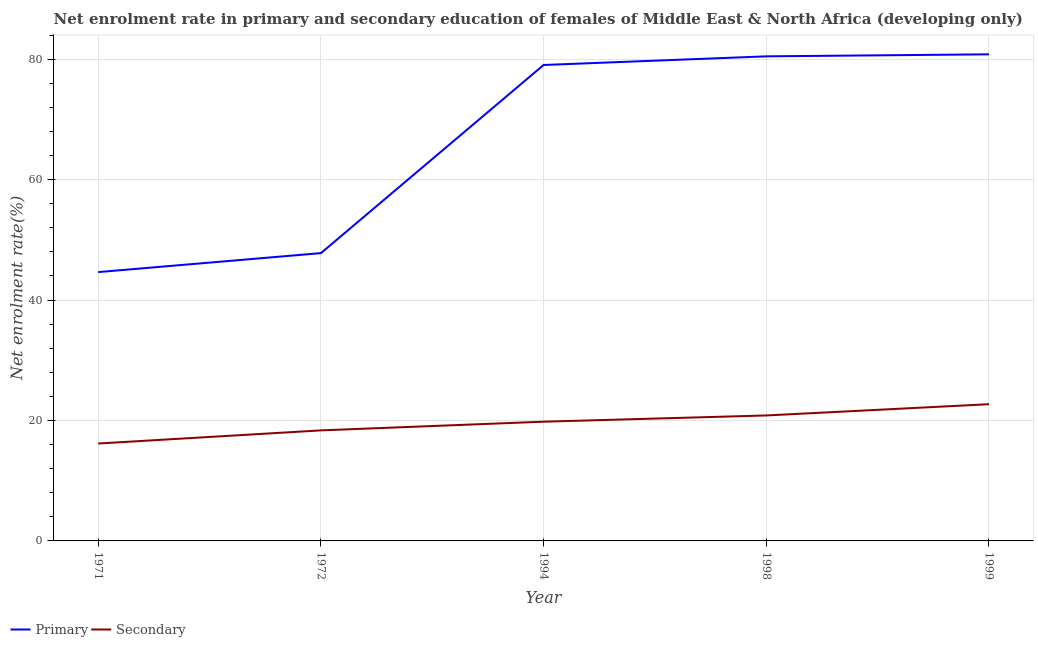How many different coloured lines are there?
Make the answer very short. 2. What is the enrollment rate in secondary education in 1972?
Offer a terse response. 18.36. Across all years, what is the maximum enrollment rate in secondary education?
Offer a terse response. 22.7. Across all years, what is the minimum enrollment rate in primary education?
Offer a very short reply. 44.64. In which year was the enrollment rate in secondary education minimum?
Provide a short and direct response. 1971. What is the total enrollment rate in secondary education in the graph?
Your answer should be very brief. 97.87. What is the difference between the enrollment rate in secondary education in 1998 and that in 1999?
Keep it short and to the point. -1.87. What is the difference between the enrollment rate in primary education in 1972 and the enrollment rate in secondary education in 1998?
Ensure brevity in your answer.  26.96. What is the average enrollment rate in primary education per year?
Offer a terse response. 66.55. In the year 1999, what is the difference between the enrollment rate in secondary education and enrollment rate in primary education?
Provide a succinct answer. -58.1. In how many years, is the enrollment rate in primary education greater than 76 %?
Offer a very short reply. 3. What is the ratio of the enrollment rate in primary education in 1994 to that in 1998?
Give a very brief answer. 0.98. What is the difference between the highest and the second highest enrollment rate in primary education?
Your response must be concise. 0.33. What is the difference between the highest and the lowest enrollment rate in secondary education?
Ensure brevity in your answer.  6.53. In how many years, is the enrollment rate in primary education greater than the average enrollment rate in primary education taken over all years?
Ensure brevity in your answer.  3. Does the enrollment rate in primary education monotonically increase over the years?
Give a very brief answer. Yes. Is the enrollment rate in secondary education strictly less than the enrollment rate in primary education over the years?
Offer a very short reply. Yes. Are the values on the major ticks of Y-axis written in scientific E-notation?
Keep it short and to the point. No. Does the graph contain any zero values?
Your answer should be very brief. No. How many legend labels are there?
Offer a very short reply. 2. What is the title of the graph?
Give a very brief answer. Net enrolment rate in primary and secondary education of females of Middle East & North Africa (developing only). Does "Primary completion rate" appear as one of the legend labels in the graph?
Offer a terse response. No. What is the label or title of the X-axis?
Give a very brief answer. Year. What is the label or title of the Y-axis?
Ensure brevity in your answer.  Net enrolment rate(%). What is the Net enrolment rate(%) in Primary in 1971?
Your answer should be compact. 44.64. What is the Net enrolment rate(%) in Secondary in 1971?
Your response must be concise. 16.17. What is the Net enrolment rate(%) of Primary in 1972?
Your response must be concise. 47.79. What is the Net enrolment rate(%) in Secondary in 1972?
Your answer should be compact. 18.36. What is the Net enrolment rate(%) in Primary in 1994?
Your answer should be very brief. 79.03. What is the Net enrolment rate(%) in Secondary in 1994?
Make the answer very short. 19.8. What is the Net enrolment rate(%) of Primary in 1998?
Give a very brief answer. 80.47. What is the Net enrolment rate(%) in Secondary in 1998?
Provide a succinct answer. 20.83. What is the Net enrolment rate(%) in Primary in 1999?
Make the answer very short. 80.8. What is the Net enrolment rate(%) in Secondary in 1999?
Keep it short and to the point. 22.7. Across all years, what is the maximum Net enrolment rate(%) in Primary?
Your response must be concise. 80.8. Across all years, what is the maximum Net enrolment rate(%) of Secondary?
Your answer should be compact. 22.7. Across all years, what is the minimum Net enrolment rate(%) in Primary?
Make the answer very short. 44.64. Across all years, what is the minimum Net enrolment rate(%) of Secondary?
Provide a short and direct response. 16.17. What is the total Net enrolment rate(%) in Primary in the graph?
Make the answer very short. 332.73. What is the total Net enrolment rate(%) in Secondary in the graph?
Give a very brief answer. 97.87. What is the difference between the Net enrolment rate(%) in Primary in 1971 and that in 1972?
Provide a short and direct response. -3.15. What is the difference between the Net enrolment rate(%) in Secondary in 1971 and that in 1972?
Make the answer very short. -2.18. What is the difference between the Net enrolment rate(%) of Primary in 1971 and that in 1994?
Your answer should be compact. -34.39. What is the difference between the Net enrolment rate(%) of Secondary in 1971 and that in 1994?
Offer a very short reply. -3.62. What is the difference between the Net enrolment rate(%) of Primary in 1971 and that in 1998?
Your response must be concise. -35.83. What is the difference between the Net enrolment rate(%) of Secondary in 1971 and that in 1998?
Your answer should be compact. -4.66. What is the difference between the Net enrolment rate(%) of Primary in 1971 and that in 1999?
Your answer should be very brief. -36.16. What is the difference between the Net enrolment rate(%) of Secondary in 1971 and that in 1999?
Ensure brevity in your answer.  -6.53. What is the difference between the Net enrolment rate(%) of Primary in 1972 and that in 1994?
Provide a short and direct response. -31.24. What is the difference between the Net enrolment rate(%) of Secondary in 1972 and that in 1994?
Offer a very short reply. -1.44. What is the difference between the Net enrolment rate(%) in Primary in 1972 and that in 1998?
Your answer should be compact. -32.68. What is the difference between the Net enrolment rate(%) of Secondary in 1972 and that in 1998?
Give a very brief answer. -2.48. What is the difference between the Net enrolment rate(%) in Primary in 1972 and that in 1999?
Ensure brevity in your answer.  -33.01. What is the difference between the Net enrolment rate(%) of Secondary in 1972 and that in 1999?
Make the answer very short. -4.35. What is the difference between the Net enrolment rate(%) of Primary in 1994 and that in 1998?
Your answer should be compact. -1.43. What is the difference between the Net enrolment rate(%) of Secondary in 1994 and that in 1998?
Your answer should be compact. -1.04. What is the difference between the Net enrolment rate(%) in Primary in 1994 and that in 1999?
Give a very brief answer. -1.77. What is the difference between the Net enrolment rate(%) in Secondary in 1994 and that in 1999?
Provide a succinct answer. -2.9. What is the difference between the Net enrolment rate(%) of Primary in 1998 and that in 1999?
Provide a succinct answer. -0.33. What is the difference between the Net enrolment rate(%) of Secondary in 1998 and that in 1999?
Give a very brief answer. -1.87. What is the difference between the Net enrolment rate(%) of Primary in 1971 and the Net enrolment rate(%) of Secondary in 1972?
Offer a very short reply. 26.28. What is the difference between the Net enrolment rate(%) in Primary in 1971 and the Net enrolment rate(%) in Secondary in 1994?
Ensure brevity in your answer.  24.84. What is the difference between the Net enrolment rate(%) in Primary in 1971 and the Net enrolment rate(%) in Secondary in 1998?
Make the answer very short. 23.81. What is the difference between the Net enrolment rate(%) in Primary in 1971 and the Net enrolment rate(%) in Secondary in 1999?
Offer a terse response. 21.94. What is the difference between the Net enrolment rate(%) in Primary in 1972 and the Net enrolment rate(%) in Secondary in 1994?
Your answer should be very brief. 27.99. What is the difference between the Net enrolment rate(%) of Primary in 1972 and the Net enrolment rate(%) of Secondary in 1998?
Offer a terse response. 26.96. What is the difference between the Net enrolment rate(%) of Primary in 1972 and the Net enrolment rate(%) of Secondary in 1999?
Your answer should be very brief. 25.09. What is the difference between the Net enrolment rate(%) of Primary in 1994 and the Net enrolment rate(%) of Secondary in 1998?
Make the answer very short. 58.2. What is the difference between the Net enrolment rate(%) in Primary in 1994 and the Net enrolment rate(%) in Secondary in 1999?
Make the answer very short. 56.33. What is the difference between the Net enrolment rate(%) in Primary in 1998 and the Net enrolment rate(%) in Secondary in 1999?
Keep it short and to the point. 57.76. What is the average Net enrolment rate(%) in Primary per year?
Offer a very short reply. 66.55. What is the average Net enrolment rate(%) of Secondary per year?
Provide a succinct answer. 19.57. In the year 1971, what is the difference between the Net enrolment rate(%) of Primary and Net enrolment rate(%) of Secondary?
Your response must be concise. 28.47. In the year 1972, what is the difference between the Net enrolment rate(%) of Primary and Net enrolment rate(%) of Secondary?
Your response must be concise. 29.43. In the year 1994, what is the difference between the Net enrolment rate(%) of Primary and Net enrolment rate(%) of Secondary?
Make the answer very short. 59.23. In the year 1998, what is the difference between the Net enrolment rate(%) of Primary and Net enrolment rate(%) of Secondary?
Your answer should be compact. 59.63. In the year 1999, what is the difference between the Net enrolment rate(%) in Primary and Net enrolment rate(%) in Secondary?
Your answer should be very brief. 58.1. What is the ratio of the Net enrolment rate(%) in Primary in 1971 to that in 1972?
Your answer should be compact. 0.93. What is the ratio of the Net enrolment rate(%) in Secondary in 1971 to that in 1972?
Offer a terse response. 0.88. What is the ratio of the Net enrolment rate(%) in Primary in 1971 to that in 1994?
Your response must be concise. 0.56. What is the ratio of the Net enrolment rate(%) of Secondary in 1971 to that in 1994?
Your answer should be very brief. 0.82. What is the ratio of the Net enrolment rate(%) in Primary in 1971 to that in 1998?
Make the answer very short. 0.55. What is the ratio of the Net enrolment rate(%) of Secondary in 1971 to that in 1998?
Ensure brevity in your answer.  0.78. What is the ratio of the Net enrolment rate(%) in Primary in 1971 to that in 1999?
Give a very brief answer. 0.55. What is the ratio of the Net enrolment rate(%) in Secondary in 1971 to that in 1999?
Keep it short and to the point. 0.71. What is the ratio of the Net enrolment rate(%) of Primary in 1972 to that in 1994?
Offer a very short reply. 0.6. What is the ratio of the Net enrolment rate(%) in Secondary in 1972 to that in 1994?
Ensure brevity in your answer.  0.93. What is the ratio of the Net enrolment rate(%) in Primary in 1972 to that in 1998?
Your answer should be compact. 0.59. What is the ratio of the Net enrolment rate(%) of Secondary in 1972 to that in 1998?
Provide a short and direct response. 0.88. What is the ratio of the Net enrolment rate(%) of Primary in 1972 to that in 1999?
Give a very brief answer. 0.59. What is the ratio of the Net enrolment rate(%) of Secondary in 1972 to that in 1999?
Offer a very short reply. 0.81. What is the ratio of the Net enrolment rate(%) in Primary in 1994 to that in 1998?
Your answer should be very brief. 0.98. What is the ratio of the Net enrolment rate(%) of Secondary in 1994 to that in 1998?
Offer a terse response. 0.95. What is the ratio of the Net enrolment rate(%) of Primary in 1994 to that in 1999?
Your answer should be very brief. 0.98. What is the ratio of the Net enrolment rate(%) in Secondary in 1994 to that in 1999?
Ensure brevity in your answer.  0.87. What is the ratio of the Net enrolment rate(%) of Primary in 1998 to that in 1999?
Your response must be concise. 1. What is the ratio of the Net enrolment rate(%) of Secondary in 1998 to that in 1999?
Offer a very short reply. 0.92. What is the difference between the highest and the second highest Net enrolment rate(%) of Primary?
Provide a succinct answer. 0.33. What is the difference between the highest and the second highest Net enrolment rate(%) in Secondary?
Give a very brief answer. 1.87. What is the difference between the highest and the lowest Net enrolment rate(%) of Primary?
Provide a short and direct response. 36.16. What is the difference between the highest and the lowest Net enrolment rate(%) in Secondary?
Provide a succinct answer. 6.53. 